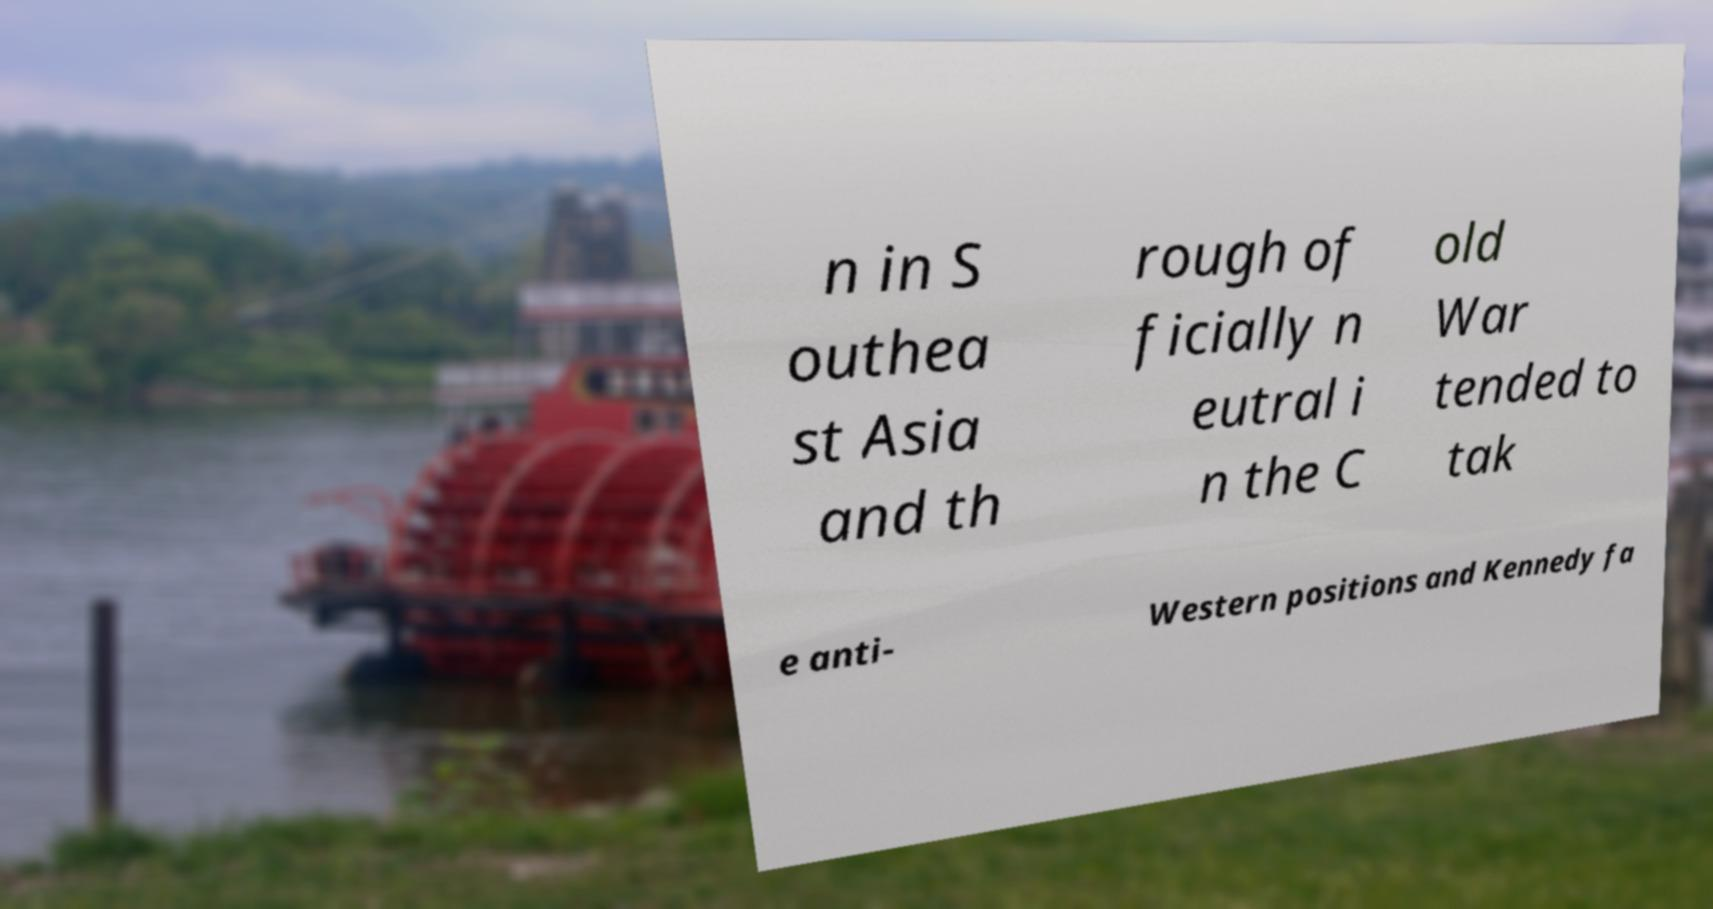Can you accurately transcribe the text from the provided image for me? n in S outhea st Asia and th rough of ficially n eutral i n the C old War tended to tak e anti- Western positions and Kennedy fa 